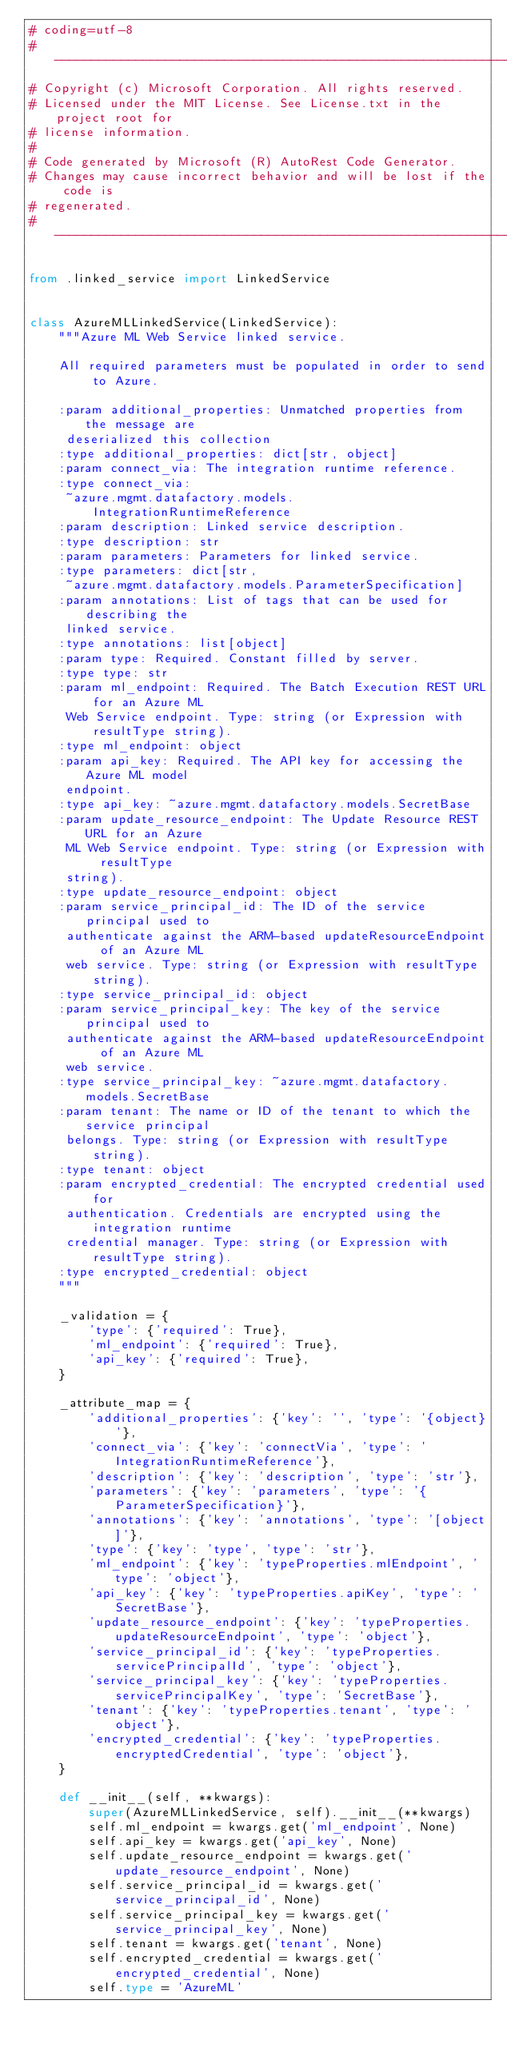Convert code to text. <code><loc_0><loc_0><loc_500><loc_500><_Python_># coding=utf-8
# --------------------------------------------------------------------------
# Copyright (c) Microsoft Corporation. All rights reserved.
# Licensed under the MIT License. See License.txt in the project root for
# license information.
#
# Code generated by Microsoft (R) AutoRest Code Generator.
# Changes may cause incorrect behavior and will be lost if the code is
# regenerated.
# --------------------------------------------------------------------------

from .linked_service import LinkedService


class AzureMLLinkedService(LinkedService):
    """Azure ML Web Service linked service.

    All required parameters must be populated in order to send to Azure.

    :param additional_properties: Unmatched properties from the message are
     deserialized this collection
    :type additional_properties: dict[str, object]
    :param connect_via: The integration runtime reference.
    :type connect_via:
     ~azure.mgmt.datafactory.models.IntegrationRuntimeReference
    :param description: Linked service description.
    :type description: str
    :param parameters: Parameters for linked service.
    :type parameters: dict[str,
     ~azure.mgmt.datafactory.models.ParameterSpecification]
    :param annotations: List of tags that can be used for describing the
     linked service.
    :type annotations: list[object]
    :param type: Required. Constant filled by server.
    :type type: str
    :param ml_endpoint: Required. The Batch Execution REST URL for an Azure ML
     Web Service endpoint. Type: string (or Expression with resultType string).
    :type ml_endpoint: object
    :param api_key: Required. The API key for accessing the Azure ML model
     endpoint.
    :type api_key: ~azure.mgmt.datafactory.models.SecretBase
    :param update_resource_endpoint: The Update Resource REST URL for an Azure
     ML Web Service endpoint. Type: string (or Expression with resultType
     string).
    :type update_resource_endpoint: object
    :param service_principal_id: The ID of the service principal used to
     authenticate against the ARM-based updateResourceEndpoint of an Azure ML
     web service. Type: string (or Expression with resultType string).
    :type service_principal_id: object
    :param service_principal_key: The key of the service principal used to
     authenticate against the ARM-based updateResourceEndpoint of an Azure ML
     web service.
    :type service_principal_key: ~azure.mgmt.datafactory.models.SecretBase
    :param tenant: The name or ID of the tenant to which the service principal
     belongs. Type: string (or Expression with resultType string).
    :type tenant: object
    :param encrypted_credential: The encrypted credential used for
     authentication. Credentials are encrypted using the integration runtime
     credential manager. Type: string (or Expression with resultType string).
    :type encrypted_credential: object
    """

    _validation = {
        'type': {'required': True},
        'ml_endpoint': {'required': True},
        'api_key': {'required': True},
    }

    _attribute_map = {
        'additional_properties': {'key': '', 'type': '{object}'},
        'connect_via': {'key': 'connectVia', 'type': 'IntegrationRuntimeReference'},
        'description': {'key': 'description', 'type': 'str'},
        'parameters': {'key': 'parameters', 'type': '{ParameterSpecification}'},
        'annotations': {'key': 'annotations', 'type': '[object]'},
        'type': {'key': 'type', 'type': 'str'},
        'ml_endpoint': {'key': 'typeProperties.mlEndpoint', 'type': 'object'},
        'api_key': {'key': 'typeProperties.apiKey', 'type': 'SecretBase'},
        'update_resource_endpoint': {'key': 'typeProperties.updateResourceEndpoint', 'type': 'object'},
        'service_principal_id': {'key': 'typeProperties.servicePrincipalId', 'type': 'object'},
        'service_principal_key': {'key': 'typeProperties.servicePrincipalKey', 'type': 'SecretBase'},
        'tenant': {'key': 'typeProperties.tenant', 'type': 'object'},
        'encrypted_credential': {'key': 'typeProperties.encryptedCredential', 'type': 'object'},
    }

    def __init__(self, **kwargs):
        super(AzureMLLinkedService, self).__init__(**kwargs)
        self.ml_endpoint = kwargs.get('ml_endpoint', None)
        self.api_key = kwargs.get('api_key', None)
        self.update_resource_endpoint = kwargs.get('update_resource_endpoint', None)
        self.service_principal_id = kwargs.get('service_principal_id', None)
        self.service_principal_key = kwargs.get('service_principal_key', None)
        self.tenant = kwargs.get('tenant', None)
        self.encrypted_credential = kwargs.get('encrypted_credential', None)
        self.type = 'AzureML'
</code> 